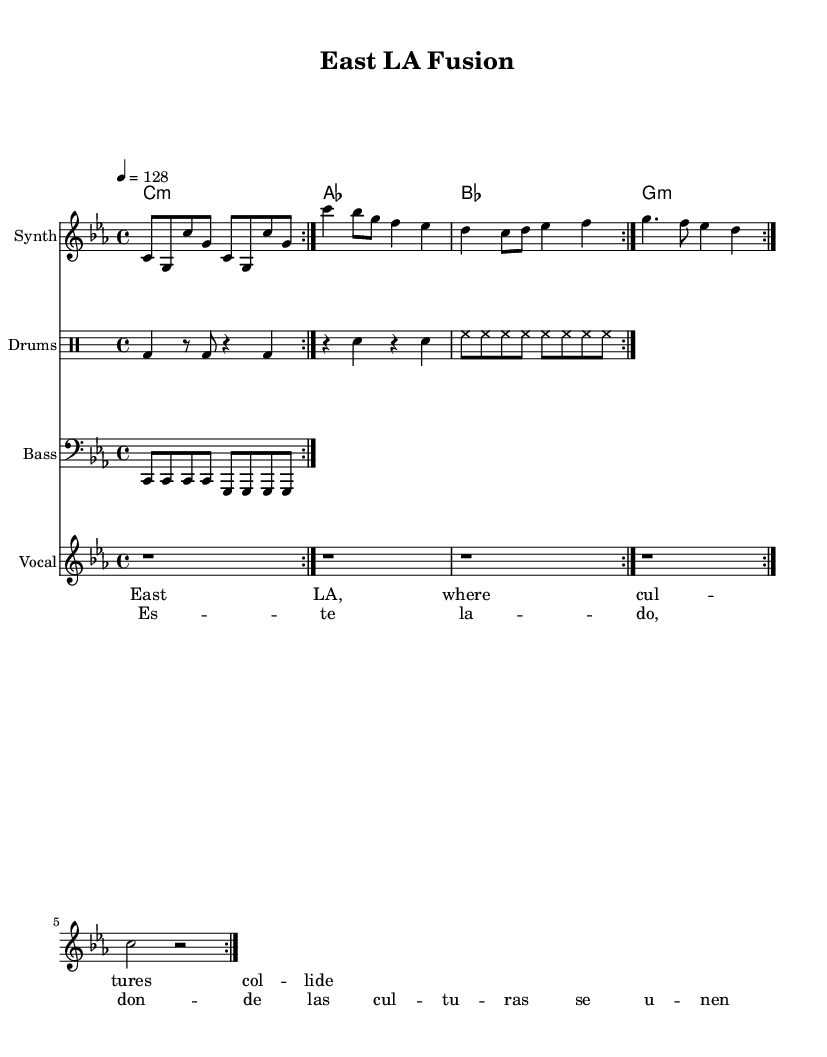What is the key signature of this music? The key signature is indicated at the beginning of the piece, and it shows C minor with three flat notes (B♭, E♭, A♭).
Answer: C minor What is the time signature of the piece? The time signature is shown at the start under the key signature, which is four beats per measure, represented as 4/4.
Answer: 4/4 What is the tempo for this music? The tempo marking indicates a speed of 128 beats per minute, which is noted above the first measure of the music.
Answer: 128 How many measures are in the synthesizer part? The synthesizer part contains repeated sections, and by counting the measures in each repeated volta, there are a total of 8 measures (2 repeated sections of 4 measures).
Answer: 8 What musical style is represented in this sheet music? The style is identified through the use of synthesizers, drum machines, and a blend of English and Spanish lyrics which reflect modern electronic hip-hop, typical of East LA's music scene.
Answer: Electronic hip-hop What types of instrumentation are used in the piece? The sheet music lists different parts, including synthesizer, drums, bass, and vocal sections, indicating a varied instrumentation typical in electronic music.
Answer: Synthesizer, drums, bass, vocal What type of lyrics are included in this piece? The lyrics are presented in both English and Spanish, showing the bilingual nature of the culture and the community from East LA.
Answer: Bilingual (English and Spanish) 